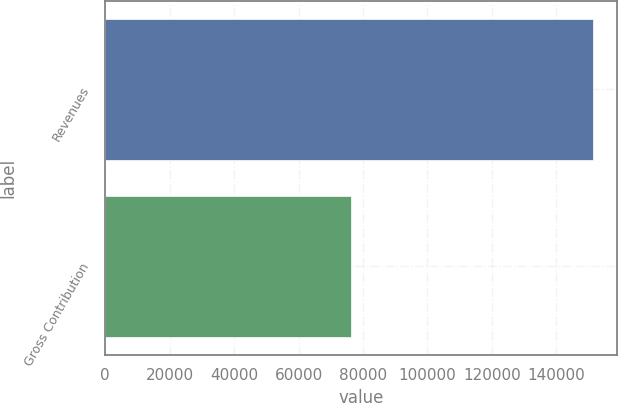Convert chart to OTSL. <chart><loc_0><loc_0><loc_500><loc_500><bar_chart><fcel>Revenues<fcel>Gross Contribution<nl><fcel>151339<fcel>76135<nl></chart> 